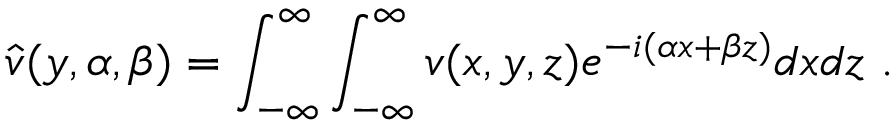<formula> <loc_0><loc_0><loc_500><loc_500>\hat { v } ( y , \alpha , \beta ) = \int _ { - \infty } ^ { \infty } \int _ { - \infty } ^ { \infty } v ( x , y , z ) e ^ { - i ( \alpha x + \beta z ) } d x d z .</formula> 